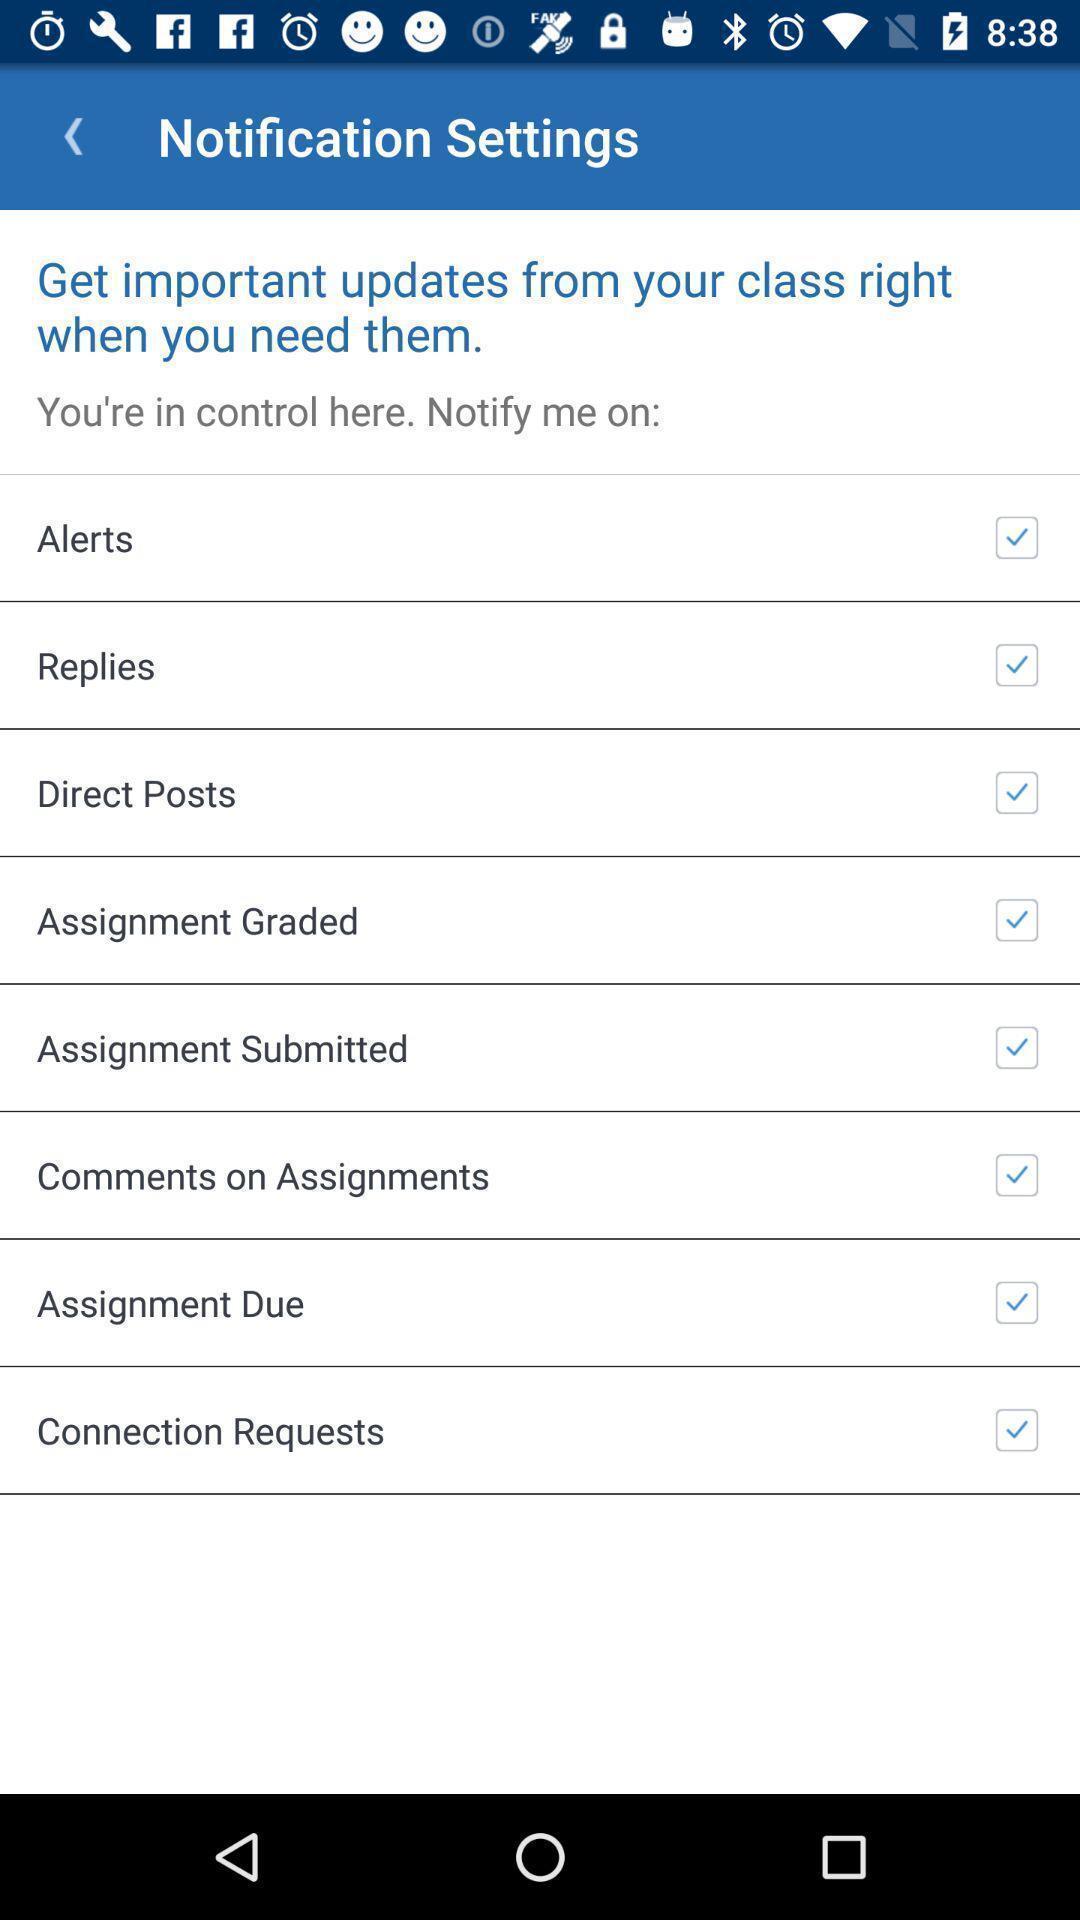Tell me what you see in this picture. Settings page for a teaching based app. 